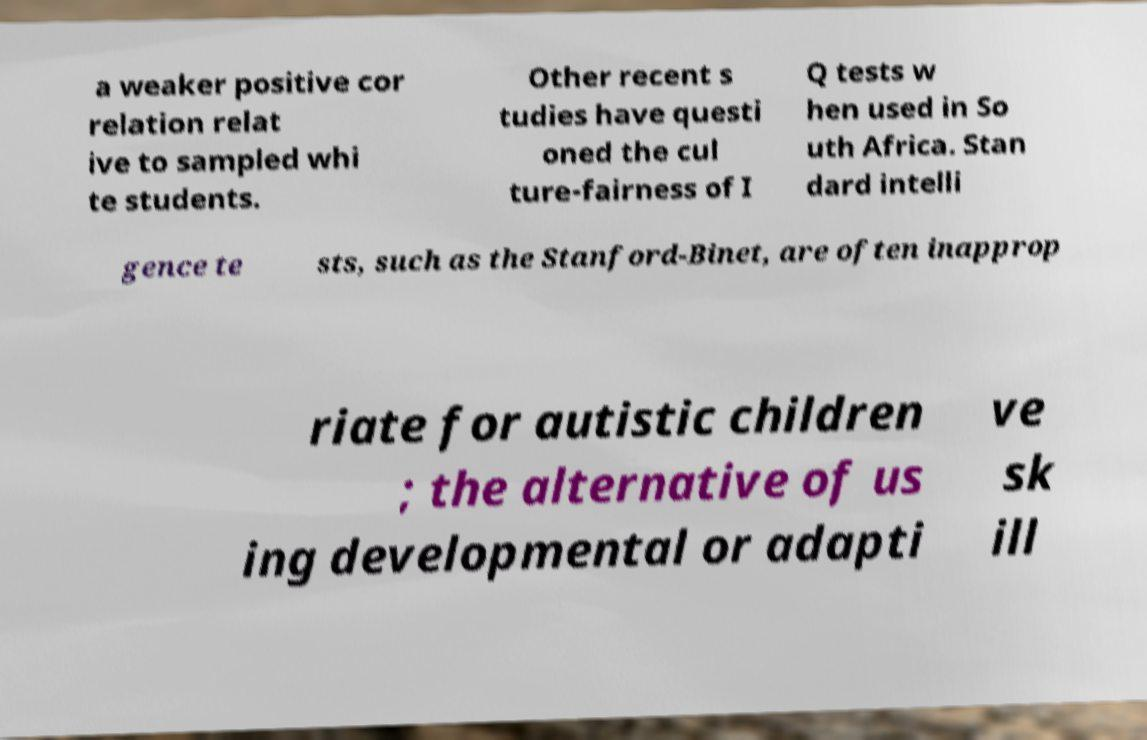Can you accurately transcribe the text from the provided image for me? a weaker positive cor relation relat ive to sampled whi te students. Other recent s tudies have questi oned the cul ture-fairness of I Q tests w hen used in So uth Africa. Stan dard intelli gence te sts, such as the Stanford-Binet, are often inapprop riate for autistic children ; the alternative of us ing developmental or adapti ve sk ill 